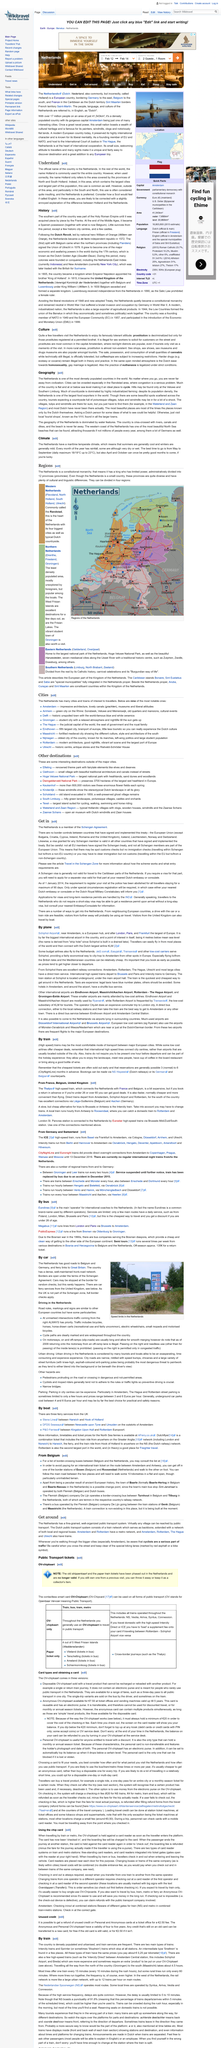Highlight a few significant elements in this photo. It takes approximately 4.5 hours to travel from the north to the south of the country by train. Red-light districts are commonly found in Amsterdam, as they are popular in many cities around the world. Intercity trains cost approximately 0.25 euros per kilometer. I am planning on staying in the Netherlands between 12-14 February. The population of the Netherlands is approximately 17 million people. 